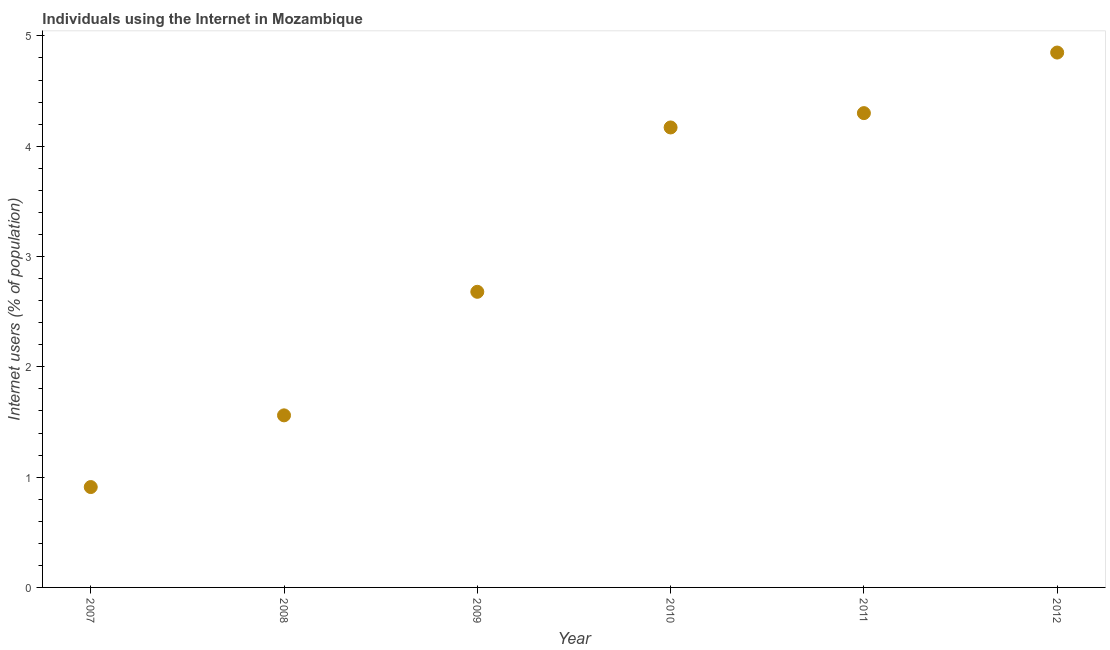What is the number of internet users in 2012?
Your answer should be very brief. 4.85. Across all years, what is the maximum number of internet users?
Keep it short and to the point. 4.85. Across all years, what is the minimum number of internet users?
Provide a short and direct response. 0.91. In which year was the number of internet users maximum?
Your response must be concise. 2012. In which year was the number of internet users minimum?
Ensure brevity in your answer.  2007. What is the sum of the number of internet users?
Provide a succinct answer. 18.47. What is the difference between the number of internet users in 2007 and 2009?
Provide a succinct answer. -1.77. What is the average number of internet users per year?
Offer a very short reply. 3.08. What is the median number of internet users?
Your answer should be compact. 3.42. What is the ratio of the number of internet users in 2008 to that in 2009?
Ensure brevity in your answer.  0.58. Is the difference between the number of internet users in 2007 and 2010 greater than the difference between any two years?
Give a very brief answer. No. What is the difference between the highest and the second highest number of internet users?
Your answer should be very brief. 0.55. What is the difference between the highest and the lowest number of internet users?
Give a very brief answer. 3.94. In how many years, is the number of internet users greater than the average number of internet users taken over all years?
Provide a short and direct response. 3. How many dotlines are there?
Provide a succinct answer. 1. What is the difference between two consecutive major ticks on the Y-axis?
Offer a very short reply. 1. Are the values on the major ticks of Y-axis written in scientific E-notation?
Keep it short and to the point. No. Does the graph contain any zero values?
Your response must be concise. No. What is the title of the graph?
Provide a succinct answer. Individuals using the Internet in Mozambique. What is the label or title of the Y-axis?
Offer a very short reply. Internet users (% of population). What is the Internet users (% of population) in 2007?
Offer a terse response. 0.91. What is the Internet users (% of population) in 2008?
Give a very brief answer. 1.56. What is the Internet users (% of population) in 2009?
Make the answer very short. 2.68. What is the Internet users (% of population) in 2010?
Ensure brevity in your answer.  4.17. What is the Internet users (% of population) in 2012?
Provide a succinct answer. 4.85. What is the difference between the Internet users (% of population) in 2007 and 2008?
Offer a terse response. -0.65. What is the difference between the Internet users (% of population) in 2007 and 2009?
Your answer should be compact. -1.77. What is the difference between the Internet users (% of population) in 2007 and 2010?
Make the answer very short. -3.26. What is the difference between the Internet users (% of population) in 2007 and 2011?
Provide a short and direct response. -3.39. What is the difference between the Internet users (% of population) in 2007 and 2012?
Ensure brevity in your answer.  -3.94. What is the difference between the Internet users (% of population) in 2008 and 2009?
Your response must be concise. -1.12. What is the difference between the Internet users (% of population) in 2008 and 2010?
Offer a very short reply. -2.61. What is the difference between the Internet users (% of population) in 2008 and 2011?
Your answer should be compact. -2.74. What is the difference between the Internet users (% of population) in 2008 and 2012?
Offer a terse response. -3.29. What is the difference between the Internet users (% of population) in 2009 and 2010?
Keep it short and to the point. -1.49. What is the difference between the Internet users (% of population) in 2009 and 2011?
Provide a succinct answer. -1.62. What is the difference between the Internet users (% of population) in 2009 and 2012?
Your answer should be compact. -2.17. What is the difference between the Internet users (% of population) in 2010 and 2011?
Offer a very short reply. -0.13. What is the difference between the Internet users (% of population) in 2010 and 2012?
Provide a succinct answer. -0.68. What is the difference between the Internet users (% of population) in 2011 and 2012?
Provide a short and direct response. -0.55. What is the ratio of the Internet users (% of population) in 2007 to that in 2008?
Your answer should be compact. 0.58. What is the ratio of the Internet users (% of population) in 2007 to that in 2009?
Provide a succinct answer. 0.34. What is the ratio of the Internet users (% of population) in 2007 to that in 2010?
Make the answer very short. 0.22. What is the ratio of the Internet users (% of population) in 2007 to that in 2011?
Provide a short and direct response. 0.21. What is the ratio of the Internet users (% of population) in 2007 to that in 2012?
Ensure brevity in your answer.  0.19. What is the ratio of the Internet users (% of population) in 2008 to that in 2009?
Your response must be concise. 0.58. What is the ratio of the Internet users (% of population) in 2008 to that in 2010?
Make the answer very short. 0.37. What is the ratio of the Internet users (% of population) in 2008 to that in 2011?
Provide a succinct answer. 0.36. What is the ratio of the Internet users (% of population) in 2008 to that in 2012?
Your response must be concise. 0.32. What is the ratio of the Internet users (% of population) in 2009 to that in 2010?
Ensure brevity in your answer.  0.64. What is the ratio of the Internet users (% of population) in 2009 to that in 2011?
Your response must be concise. 0.62. What is the ratio of the Internet users (% of population) in 2009 to that in 2012?
Provide a short and direct response. 0.55. What is the ratio of the Internet users (% of population) in 2010 to that in 2011?
Give a very brief answer. 0.97. What is the ratio of the Internet users (% of population) in 2010 to that in 2012?
Your answer should be compact. 0.86. What is the ratio of the Internet users (% of population) in 2011 to that in 2012?
Make the answer very short. 0.89. 